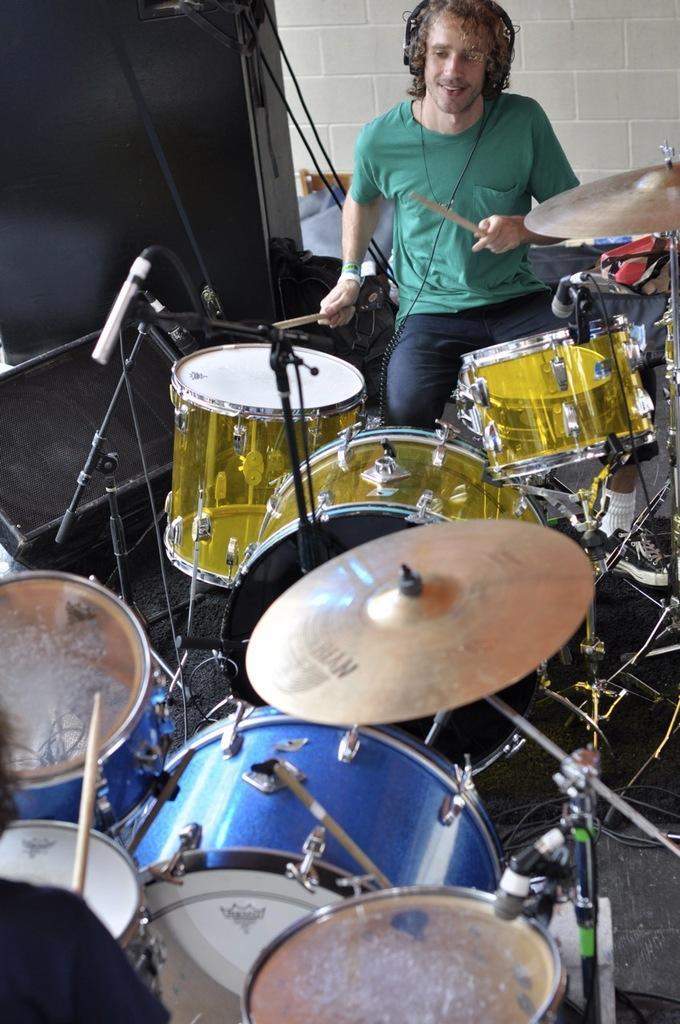In one or two sentences, can you explain what this image depicts? In this image we can see a man sitting and playing a band. In the background there is a wall. At the bottom there are wires. 